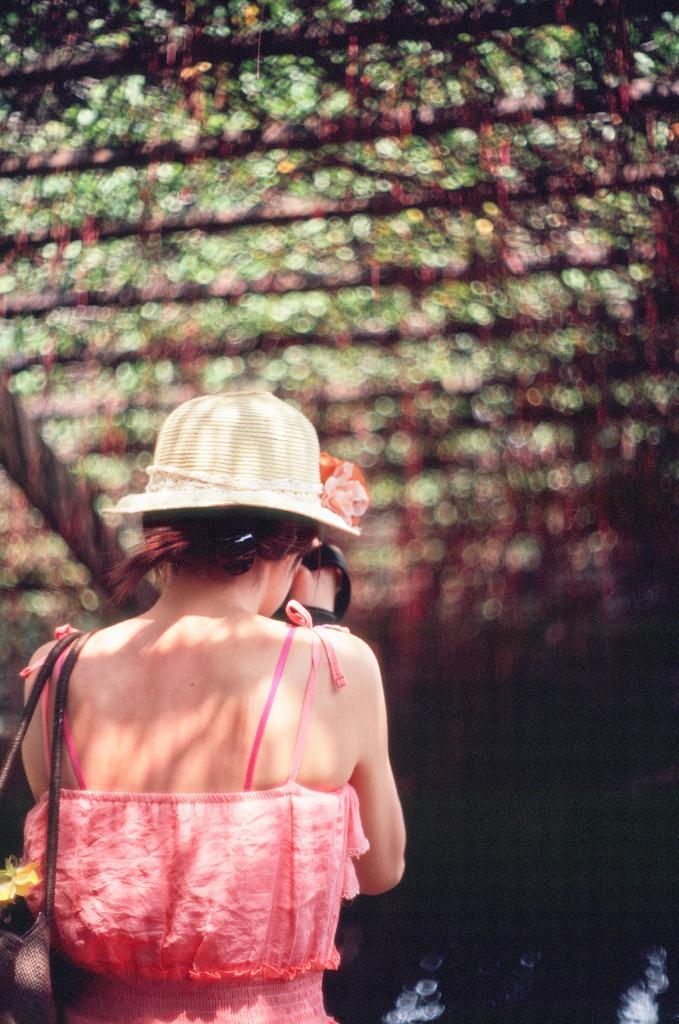Could you give a brief overview of what you see in this image? In this picture there is a girl on the left side of the image and the background area of the image is blurred. 